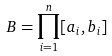<formula> <loc_0><loc_0><loc_500><loc_500>B = \prod _ { i = 1 } ^ { n } [ a _ { i } , b _ { i } ]</formula> 